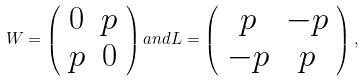Convert formula to latex. <formula><loc_0><loc_0><loc_500><loc_500>W = \left ( \begin{array} { c c } 0 & p \\ p & 0 \end{array} \right ) a n d L = \left ( \begin{array} { c c } p & - p \\ - p & p \end{array} \right ) ,</formula> 